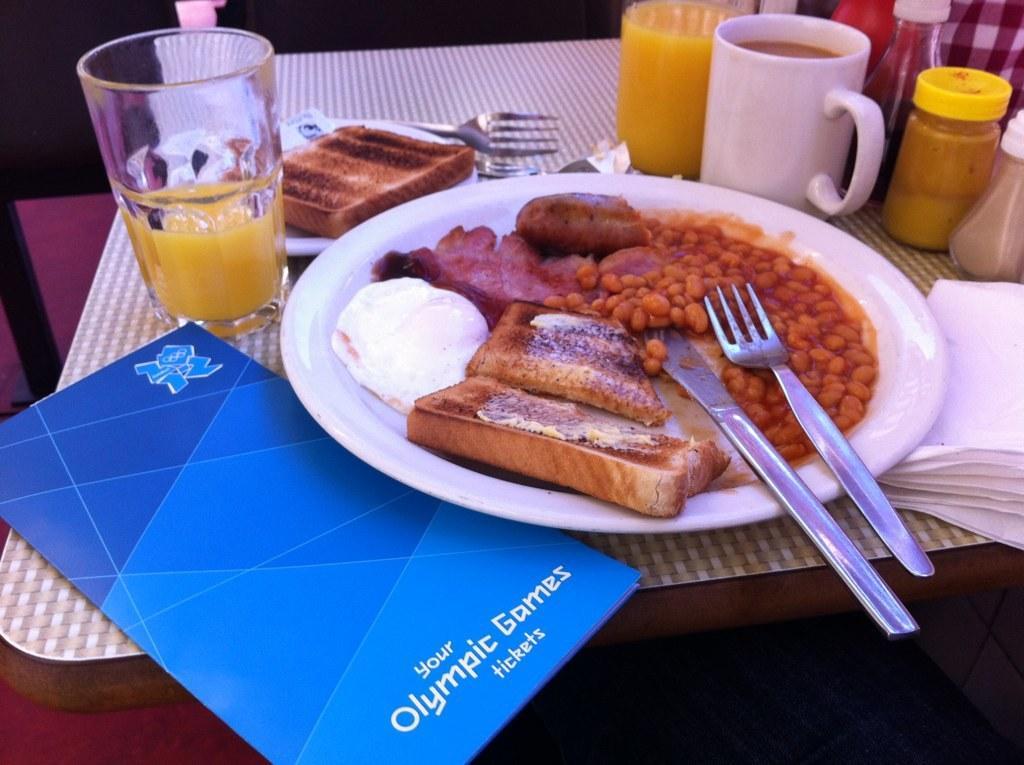Please provide a concise description of this image. In this picture we can see a table and on the table, there are plates, glasses, a cup, forks, knife, card, tissues and other objects. There are food items in the plates. Behind the table, there is a dark background. 